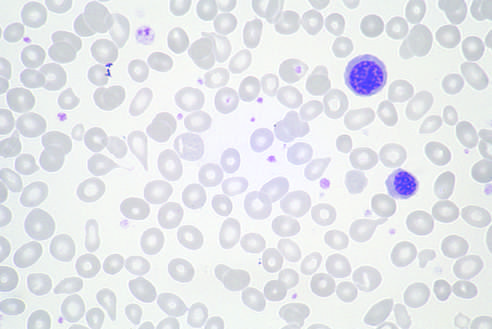how are two nucleated erythroid precursors and several teardrop-shaped red cells?
Answer the question using a single word or phrase. Evident 